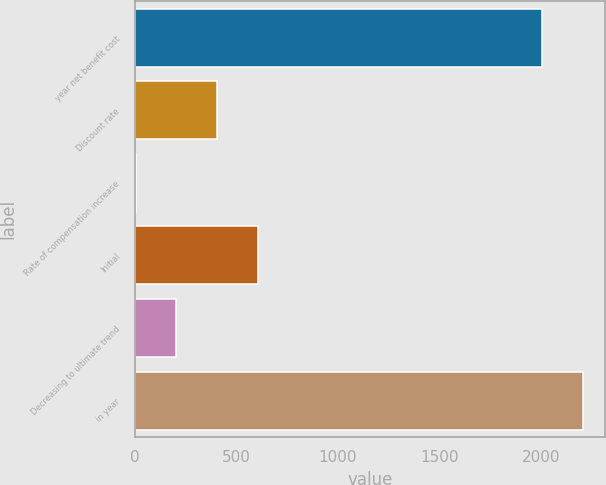Convert chart to OTSL. <chart><loc_0><loc_0><loc_500><loc_500><bar_chart><fcel>year net benefit cost<fcel>Discount rate<fcel>Rate of compensation increase<fcel>Initial<fcel>Decreasing to ultimate trend<fcel>in year<nl><fcel>2005<fcel>404.81<fcel>3.75<fcel>605.34<fcel>204.28<fcel>2205.53<nl></chart> 